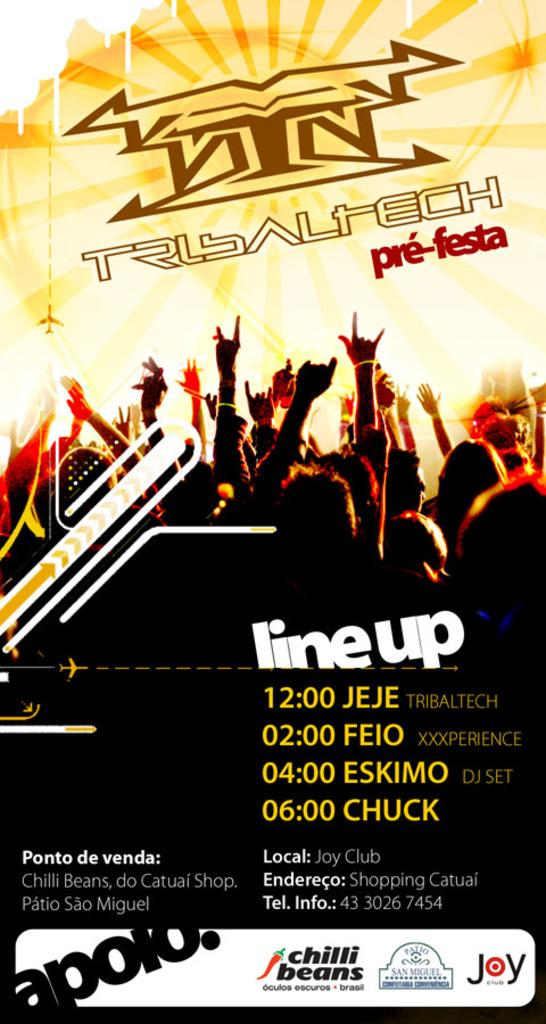Provide a one-sentence caption for the provided image. Poster for a concert that is taking place at Joy Club. 